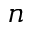Convert formula to latex. <formula><loc_0><loc_0><loc_500><loc_500>n</formula> 